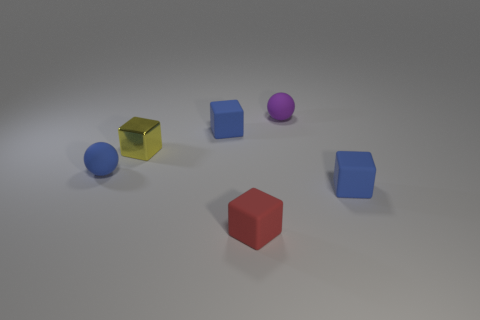Subtract all green cylinders. How many blue blocks are left? 2 Subtract all small rubber cubes. How many cubes are left? 1 Subtract all red blocks. How many blocks are left? 3 Add 3 red cubes. How many objects exist? 9 Subtract 1 blocks. How many blocks are left? 3 Subtract all gray blocks. Subtract all gray cylinders. How many blocks are left? 4 Subtract all balls. How many objects are left? 4 Add 5 rubber spheres. How many rubber spheres exist? 7 Subtract 0 brown cylinders. How many objects are left? 6 Subtract all purple metallic objects. Subtract all small metallic cubes. How many objects are left? 5 